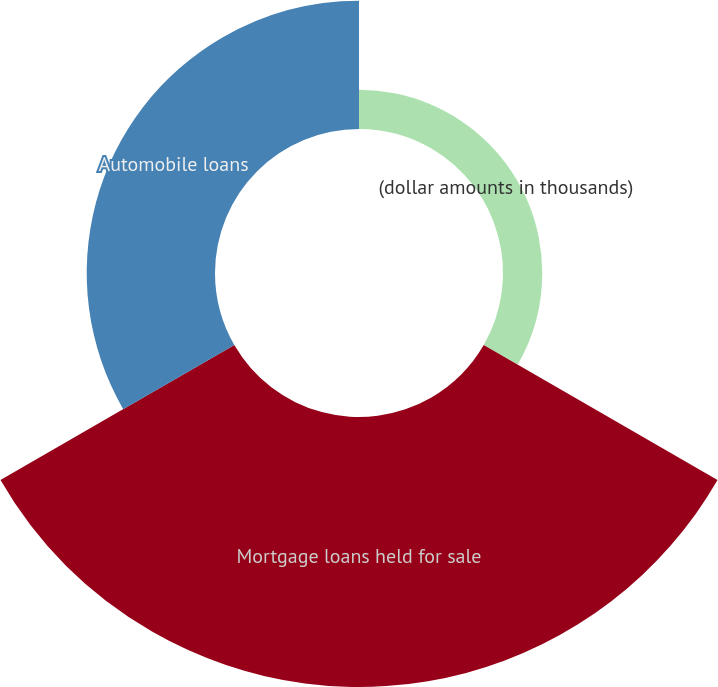<chart> <loc_0><loc_0><loc_500><loc_500><pie_chart><fcel>(dollar amounts in thousands)<fcel>Mortgage loans held for sale<fcel>Automobile loans<nl><fcel>8.97%<fcel>61.71%<fcel>29.32%<nl></chart> 